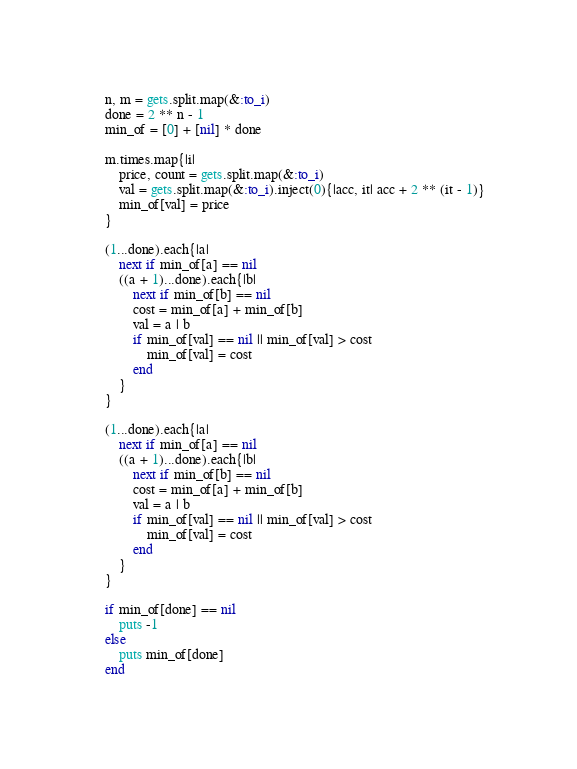<code> <loc_0><loc_0><loc_500><loc_500><_Ruby_>n, m = gets.split.map(&:to_i)
done = 2 ** n - 1
min_of = [0] + [nil] * done

m.times.map{|i|
    price, count = gets.split.map(&:to_i)
    val = gets.split.map(&:to_i).inject(0){|acc, it| acc + 2 ** (it - 1)}
    min_of[val] = price
}

(1...done).each{|a|
    next if min_of[a] == nil
    ((a + 1)...done).each{|b|
        next if min_of[b] == nil
        cost = min_of[a] + min_of[b]
        val = a | b
        if min_of[val] == nil || min_of[val] > cost
            min_of[val] = cost
        end
    }    
}

(1...done).each{|a|
    next if min_of[a] == nil
    ((a + 1)...done).each{|b|
        next if min_of[b] == nil
        cost = min_of[a] + min_of[b]
        val = a | b
        if min_of[val] == nil || min_of[val] > cost
            min_of[val] = cost
        end
    }    
}

if min_of[done] == nil
    puts -1
else
    puts min_of[done]
end</code> 